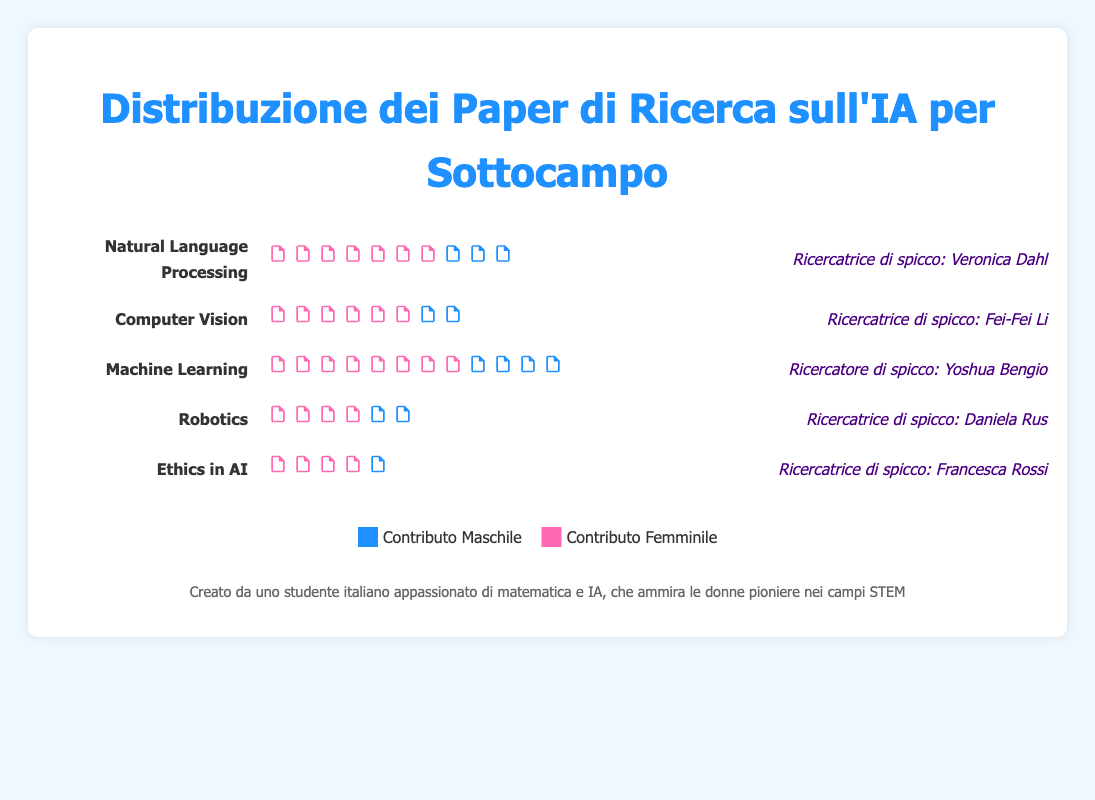What is the title of the figure? The title of the figure is located at the top in larger text. It gives an overview of what the plot is about: "Distribuzione dei Paper di Ricerca sull'IA per Sottocampo"
Answer: Distribuzione dei Paper di Ricerca sull'IA per Sottocampo Which AI subfield has the highest number of total research papers? By counting the paper icons of each subfield, the one with the most is Machine Learning. Each icon represents one paper and Machine Learning has 120 papers.
Answer: Machine Learning What's the percentage of female contributions in the Ethics in AI subfield? The Ethics in AI subfield has 22 female papers out of a total of 40. The percentage is calculated as (22/40) * 100, which equals 55%.
Answer: 55% Which subfield has the highest percentage of female contributions? Calculate the percentages for each subfield: NLP (35%), CV (35%), ML (35%), Robotics (40%), Ethics in AI (55%). The highest is found in Ethics in AI with 55%.
Answer: Ethics in AI Compare the total number of papers in Computer Vision with the number of female contributions in Natural Language Processing. Which is higher? Computer Vision has 80 total papers, and Natural Language Processing has 35 female contributions. 80 (total CV) is greater than 35 (female NLP).
Answer: Computer Vision total papers Who is the notable female researcher associated with the Robotics subfield? The notable researcher is mentioned at the end of the row labeled Robotics, and is named Daniela Rus
Answer: Daniela Rus How does the number of male contributions in Natural Language Processing compare to that in Ethics in AI? In NLP, there are 65 male contributions (total 100 - female 35), and in Ethics in AI, there are 18 male contributions (total 40 - female 22). 65 is greater than 18.
Answer: Natural Language Processing What is the combined number of female contributions in Computer Vision and Robotics? Adding the female contributions for Computer Vision (28) and Robotics (24) gives 28 + 24 = 52
Answer: 52 Which subfield has a greater proportion of female contributions, Machine Learning or Robotics? Calculate the proportions: Machine Learning 42/120 = 35% and Robotics 24/60 = 40%. Robotics has a greater proportion of female contributions.
Answer: Robotics Identify the subfield with the smallest total number of research papers. By counting each subfield's total number of papers: NLP (100), CV (80), ML (120), Robotics (60), Ethics in AI (40). Ethics in AI has the fewest with 40.
Answer: Ethics in AI 